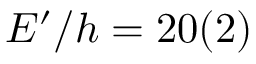Convert formula to latex. <formula><loc_0><loc_0><loc_500><loc_500>E ^ { \prime } / h = 2 0 ( 2 )</formula> 